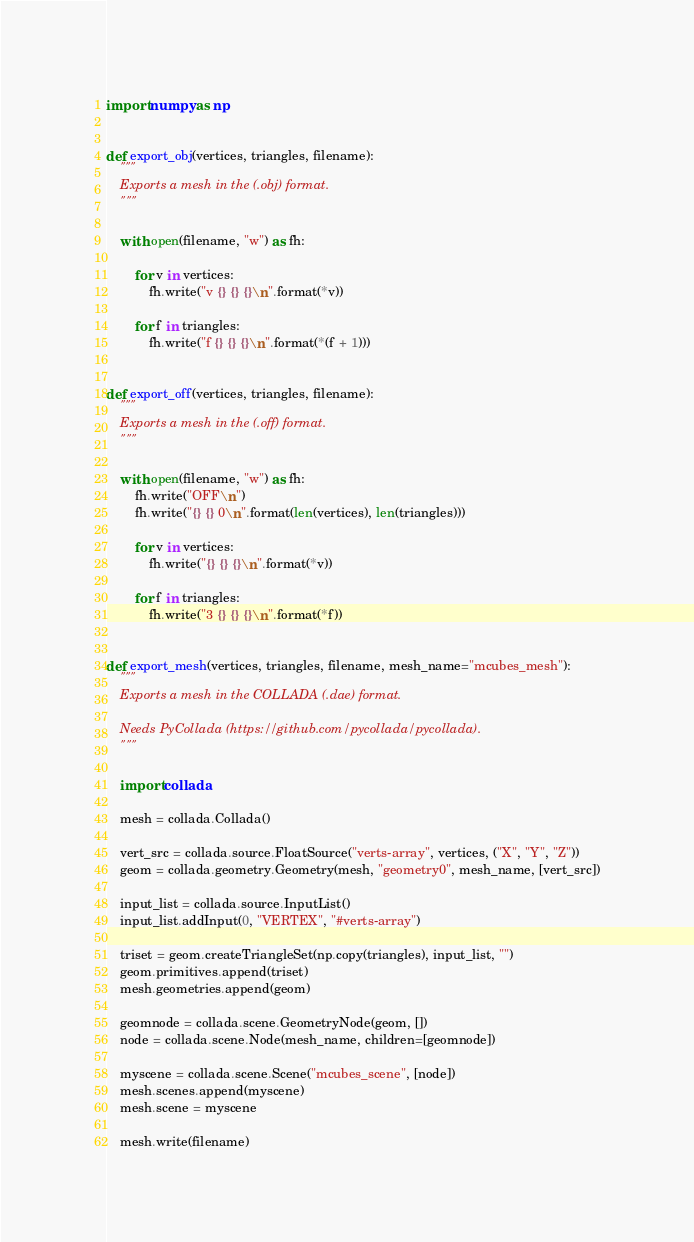Convert code to text. <code><loc_0><loc_0><loc_500><loc_500><_Python_>import numpy as np


def export_obj(vertices, triangles, filename):
    """
    Exports a mesh in the (.obj) format.
    """

    with open(filename, "w") as fh:

        for v in vertices:
            fh.write("v {} {} {}\n".format(*v))

        for f in triangles:
            fh.write("f {} {} {}\n".format(*(f + 1)))


def export_off(vertices, triangles, filename):
    """
    Exports a mesh in the (.off) format.
    """

    with open(filename, "w") as fh:
        fh.write("OFF\n")
        fh.write("{} {} 0\n".format(len(vertices), len(triangles)))

        for v in vertices:
            fh.write("{} {} {}\n".format(*v))

        for f in triangles:
            fh.write("3 {} {} {}\n".format(*f))


def export_mesh(vertices, triangles, filename, mesh_name="mcubes_mesh"):
    """
    Exports a mesh in the COLLADA (.dae) format.

    Needs PyCollada (https://github.com/pycollada/pycollada).
    """

    import collada

    mesh = collada.Collada()

    vert_src = collada.source.FloatSource("verts-array", vertices, ("X", "Y", "Z"))
    geom = collada.geometry.Geometry(mesh, "geometry0", mesh_name, [vert_src])

    input_list = collada.source.InputList()
    input_list.addInput(0, "VERTEX", "#verts-array")

    triset = geom.createTriangleSet(np.copy(triangles), input_list, "")
    geom.primitives.append(triset)
    mesh.geometries.append(geom)

    geomnode = collada.scene.GeometryNode(geom, [])
    node = collada.scene.Node(mesh_name, children=[geomnode])

    myscene = collada.scene.Scene("mcubes_scene", [node])
    mesh.scenes.append(myscene)
    mesh.scene = myscene

    mesh.write(filename)
</code> 